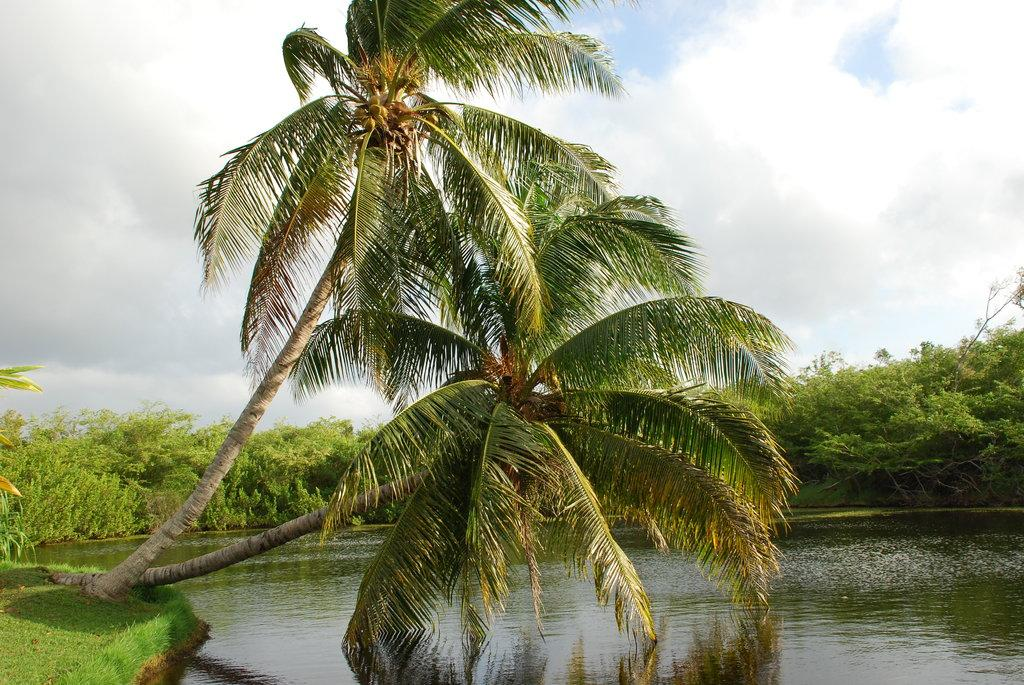What type of vegetation can be seen in the image? There are trees in the image. What is the color of the trees? The trees are green in color. What else is visible in the image besides the trees? There is water and the sky visible in the image. What colors can be seen in the sky? The sky has white and blue colors. How many lizards are sitting on the bed in the image? There is no bed or lizards present in the image. 